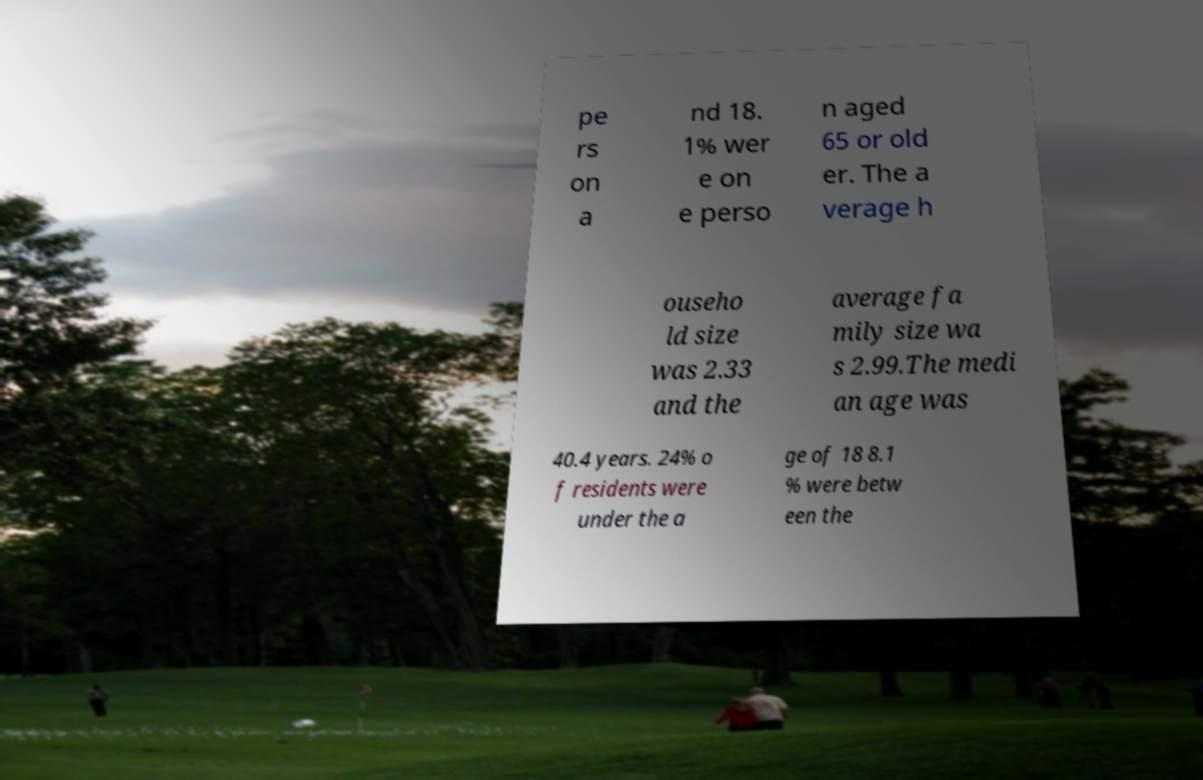What messages or text are displayed in this image? I need them in a readable, typed format. pe rs on a nd 18. 1% wer e on e perso n aged 65 or old er. The a verage h ouseho ld size was 2.33 and the average fa mily size wa s 2.99.The medi an age was 40.4 years. 24% o f residents were under the a ge of 18 8.1 % were betw een the 